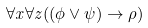<formula> <loc_0><loc_0><loc_500><loc_500>\forall x \forall z ( ( \phi \vee \psi ) \rightarrow \rho )</formula> 